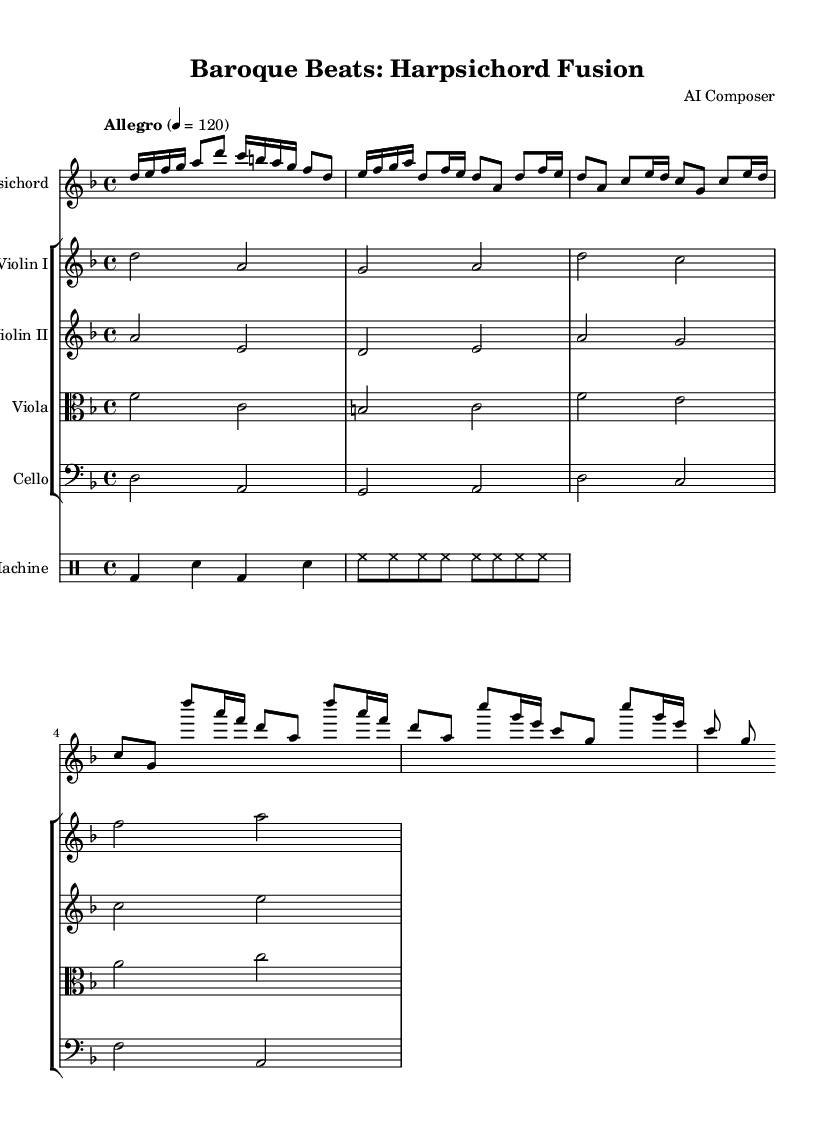What is the key signature of this music? The key signature is indicated at the beginning of the staff and shows two flats (B flat and E flat), identifying it as D minor.
Answer: D minor What is the time signature of this music? The time signature is represented at the beginning of the score, displayed as 4/4, indicating four beats per measure with a quarter note receiving one beat.
Answer: 4/4 What is the tempo marking provided? The tempo marking is written above the staff, stating "Allegro" with a metronome marking of 120, indicating a lively pace.
Answer: Allegro, 120 How many violin parts are present in this score? The score contains two distinct parts for the violin, labeled as Violin I and Violin II, each with their own staff.
Answer: Two What type of rhythmic pattern is being used in the drum part? The drum pattern notated shows a basic hip-hop structure, consisting of bass drum and snare hits along with hi-hat rhythms, characteristic of hip-hop music.
Answer: Hip-hop What instruments are included in the chamber group apart from the harpsichord? The score lists additional instruments which include Violin I, Violin II, Viola, and Cello, creating a rich chamber ensemble alongside the harpsichord.
Answer: Violin I, Violin II, Viola, Cello What is the overall character of the piece as suggested by its title? The title "Baroque Beats: Harpsichord Fusion" implies a blending of traditional Baroque elements with modern hip-hop influences, showcasing a hybrid musical style.
Answer: Fusion 